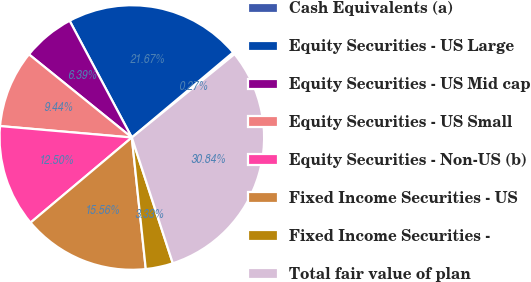Convert chart. <chart><loc_0><loc_0><loc_500><loc_500><pie_chart><fcel>Cash Equivalents (a)<fcel>Equity Securities - US Large<fcel>Equity Securities - US Mid cap<fcel>Equity Securities - US Small<fcel>Equity Securities - Non-US (b)<fcel>Fixed Income Securities - US<fcel>Fixed Income Securities -<fcel>Total fair value of plan<nl><fcel>0.27%<fcel>21.67%<fcel>6.39%<fcel>9.44%<fcel>12.5%<fcel>15.56%<fcel>3.33%<fcel>30.84%<nl></chart> 